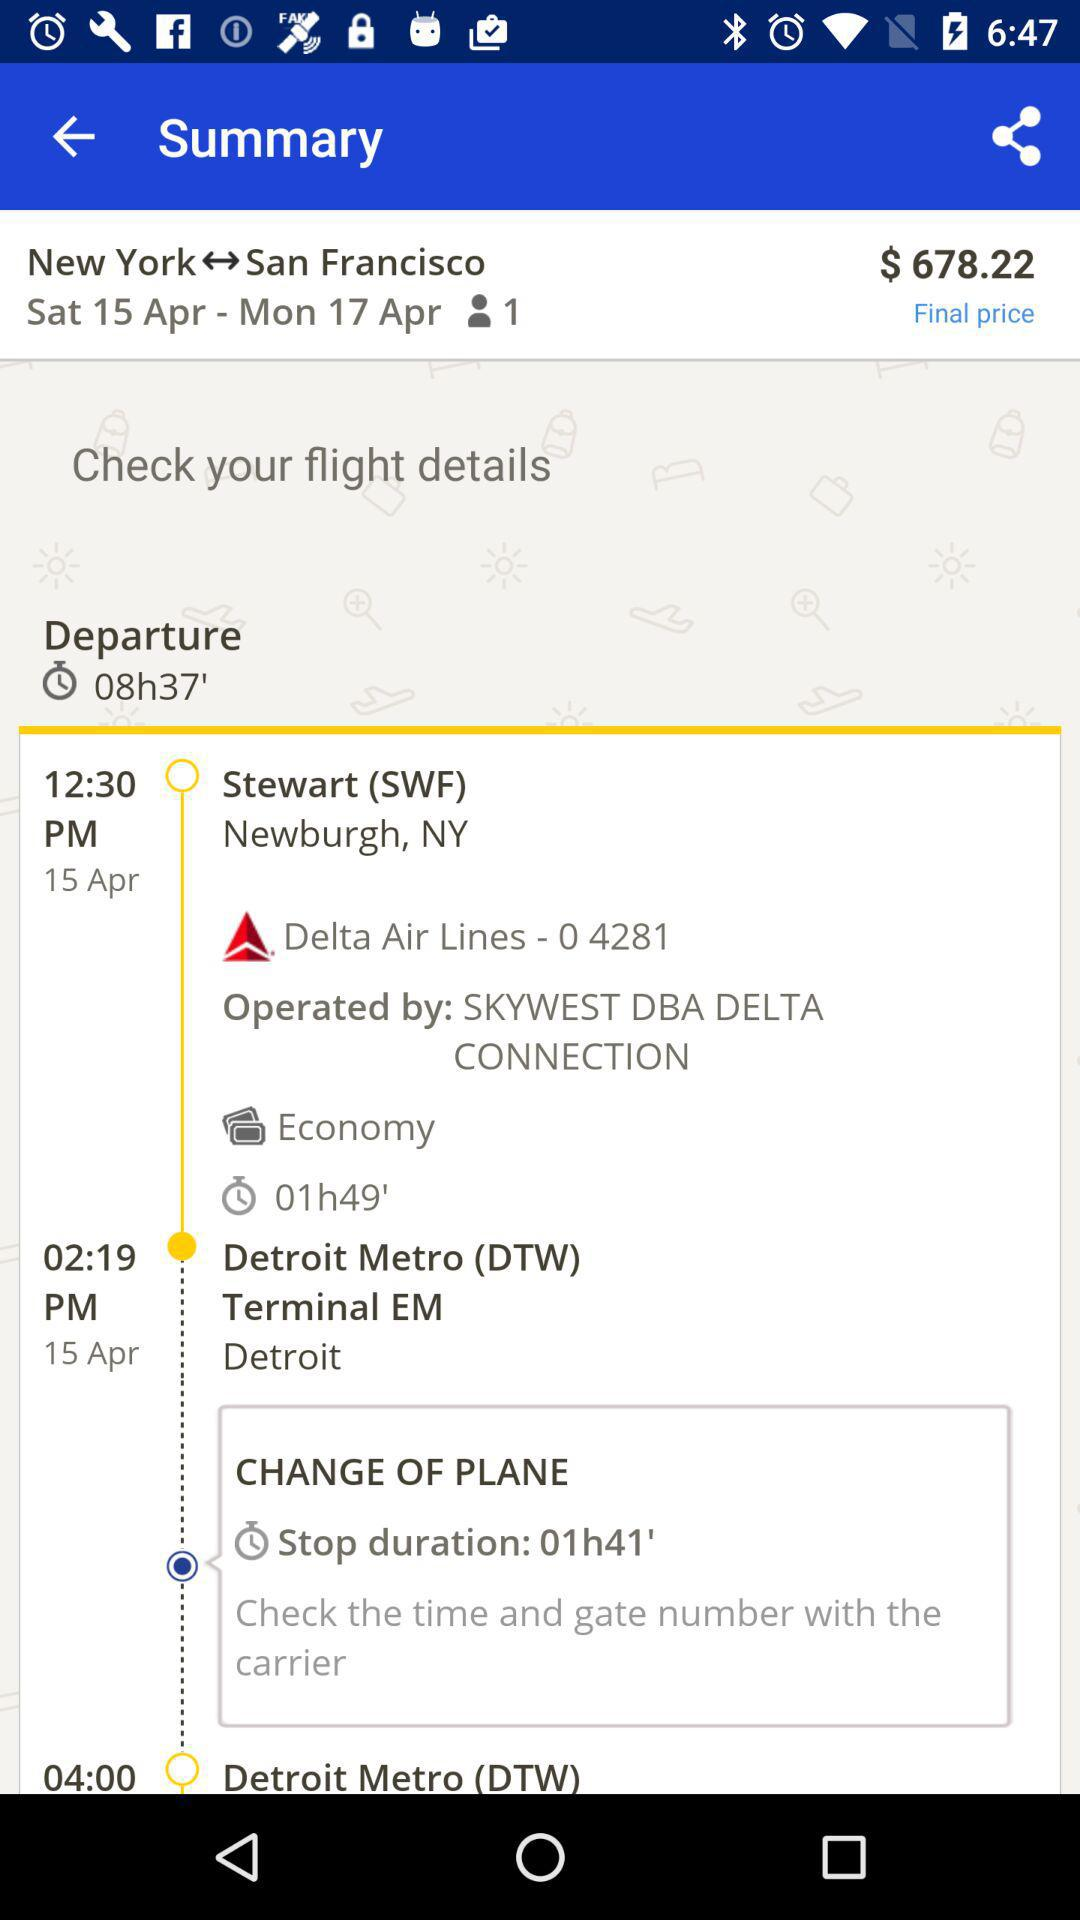How many travellers are there? There is one traveller. 